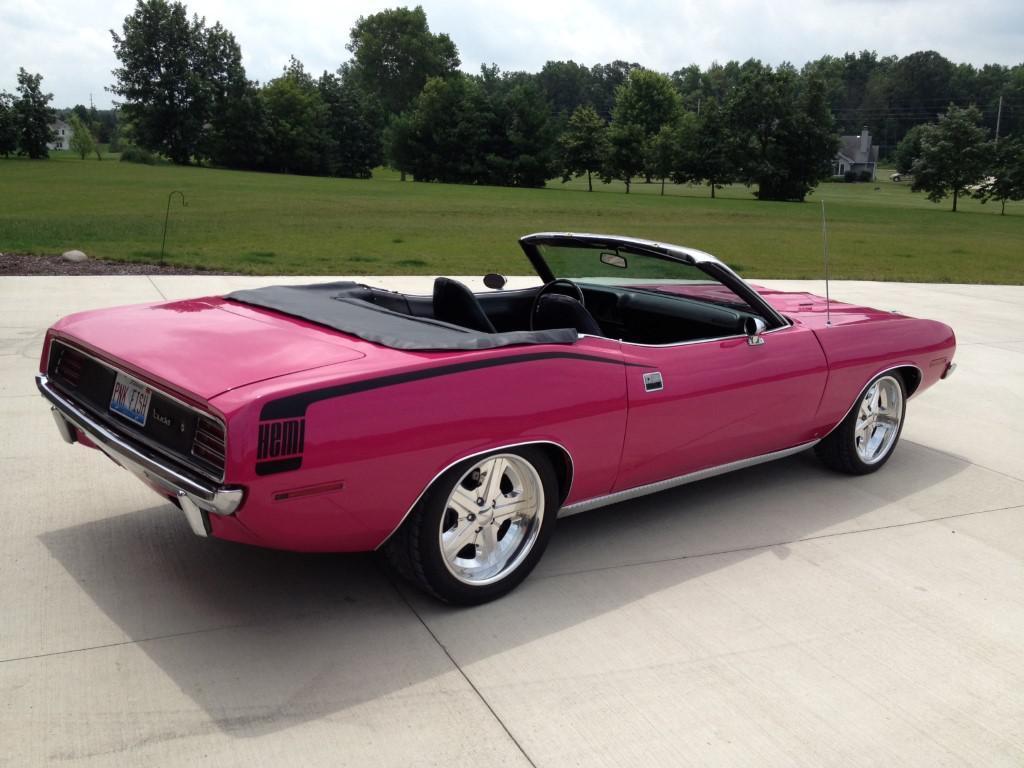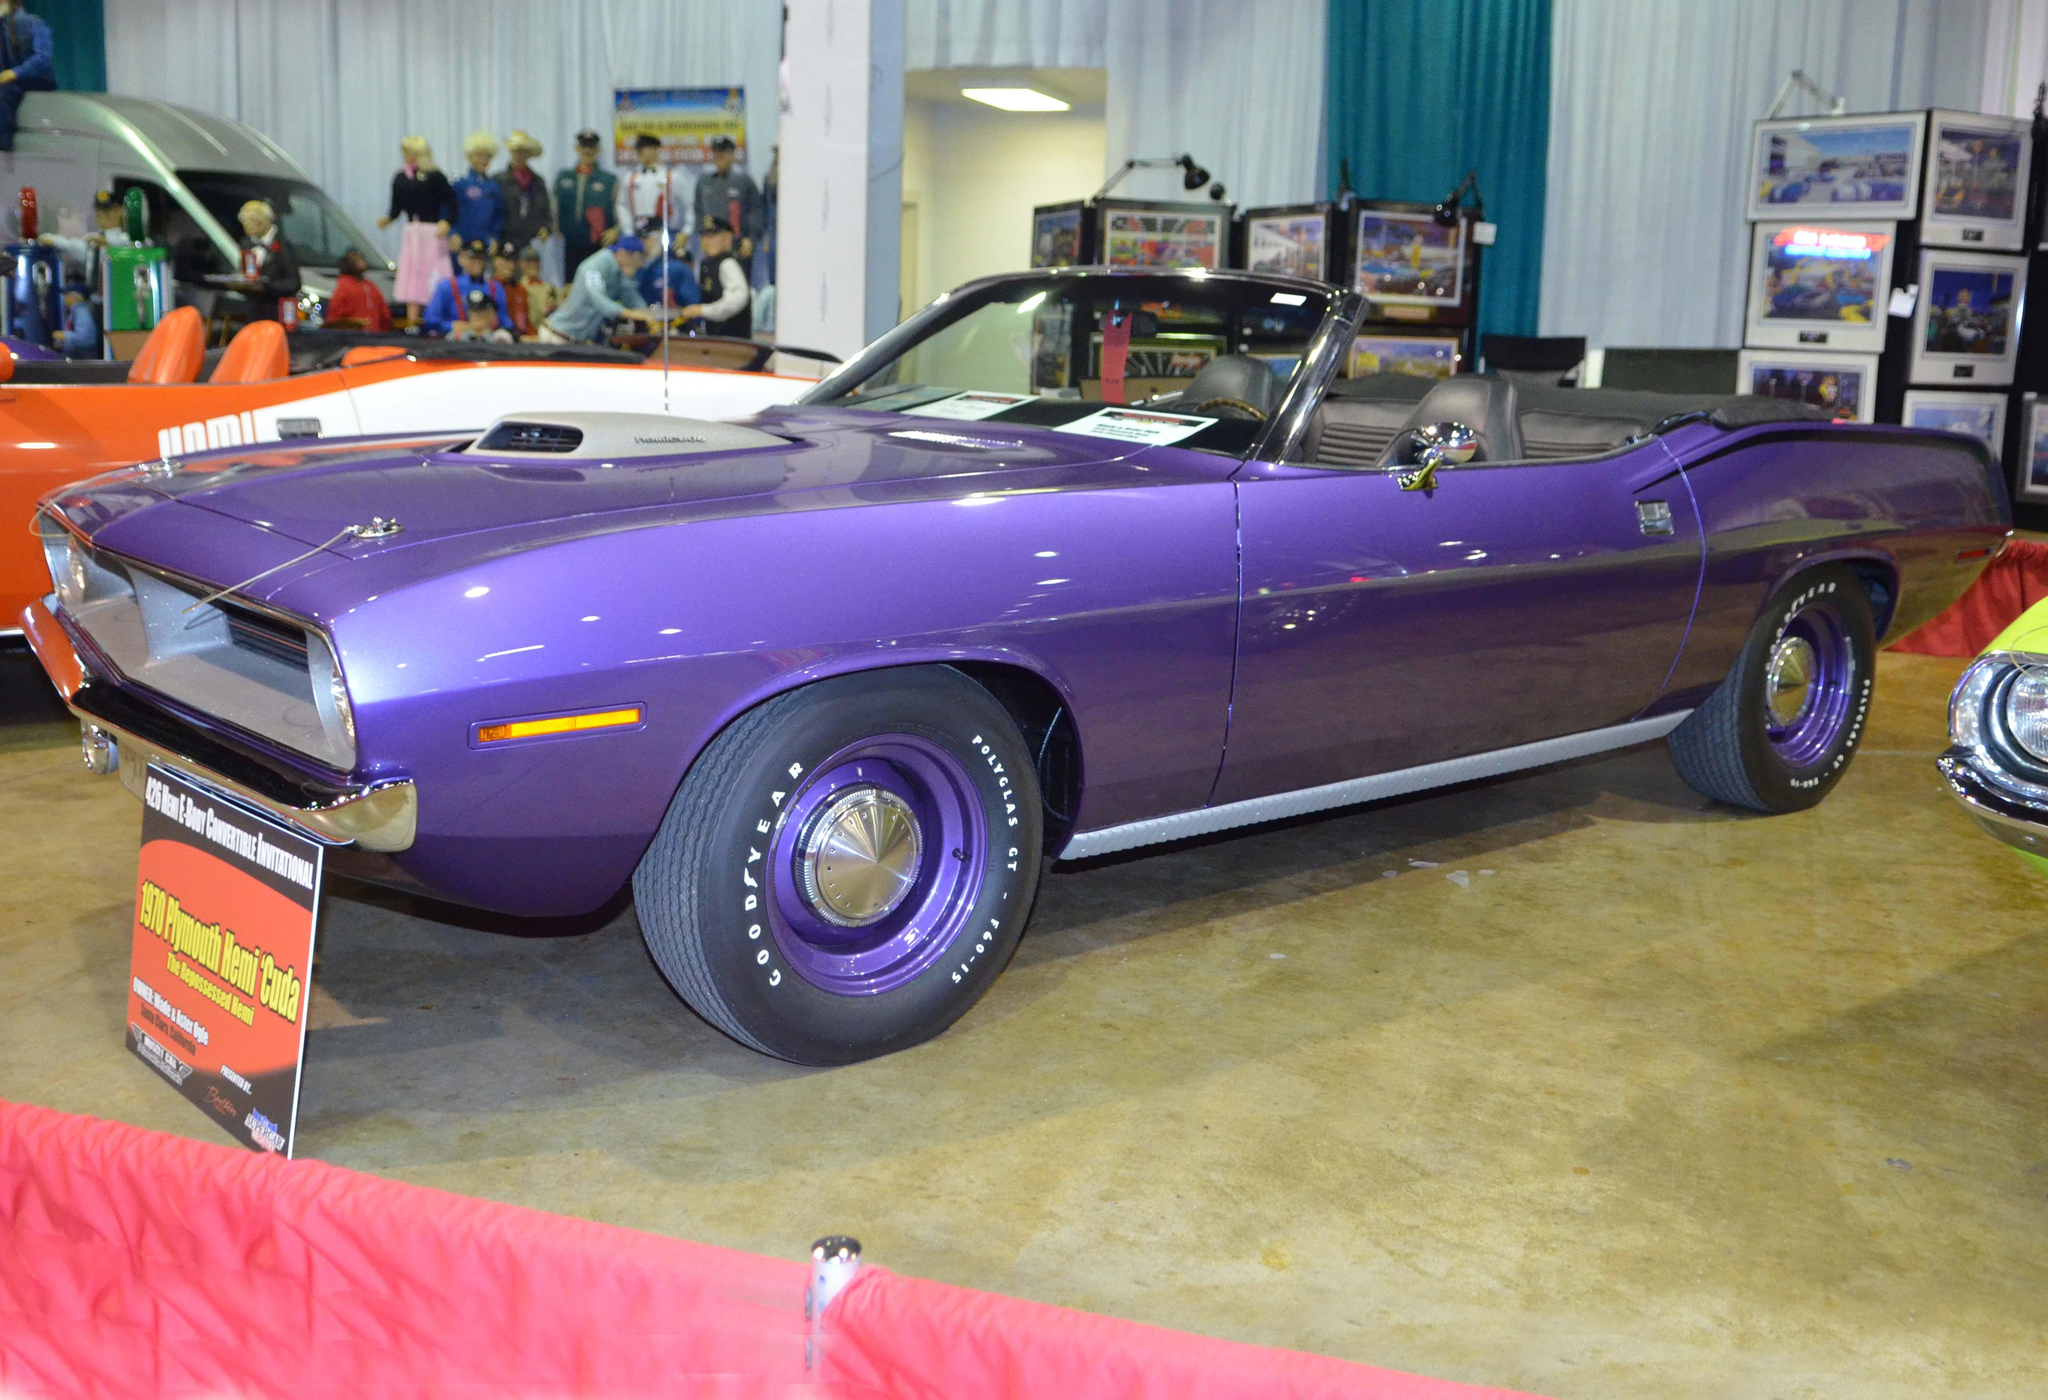The first image is the image on the left, the second image is the image on the right. Given the left and right images, does the statement "At least one image features a yellow car in the foreground." hold true? Answer yes or no. No. 